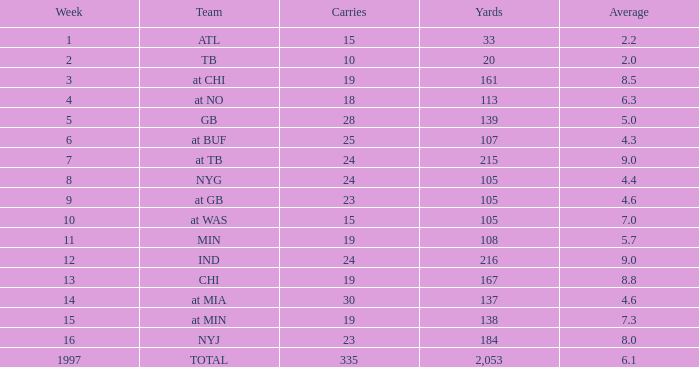In which yards are there carries less than 23, with a team at chi, and an average smaller than None. 